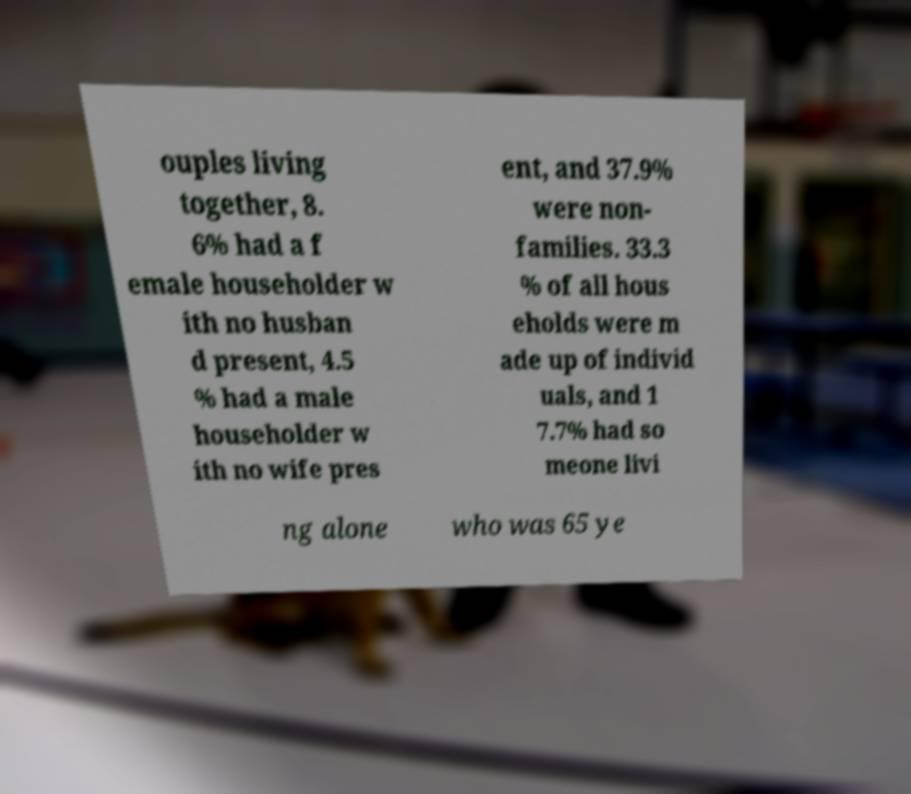Could you extract and type out the text from this image? ouples living together, 8. 6% had a f emale householder w ith no husban d present, 4.5 % had a male householder w ith no wife pres ent, and 37.9% were non- families. 33.3 % of all hous eholds were m ade up of individ uals, and 1 7.7% had so meone livi ng alone who was 65 ye 